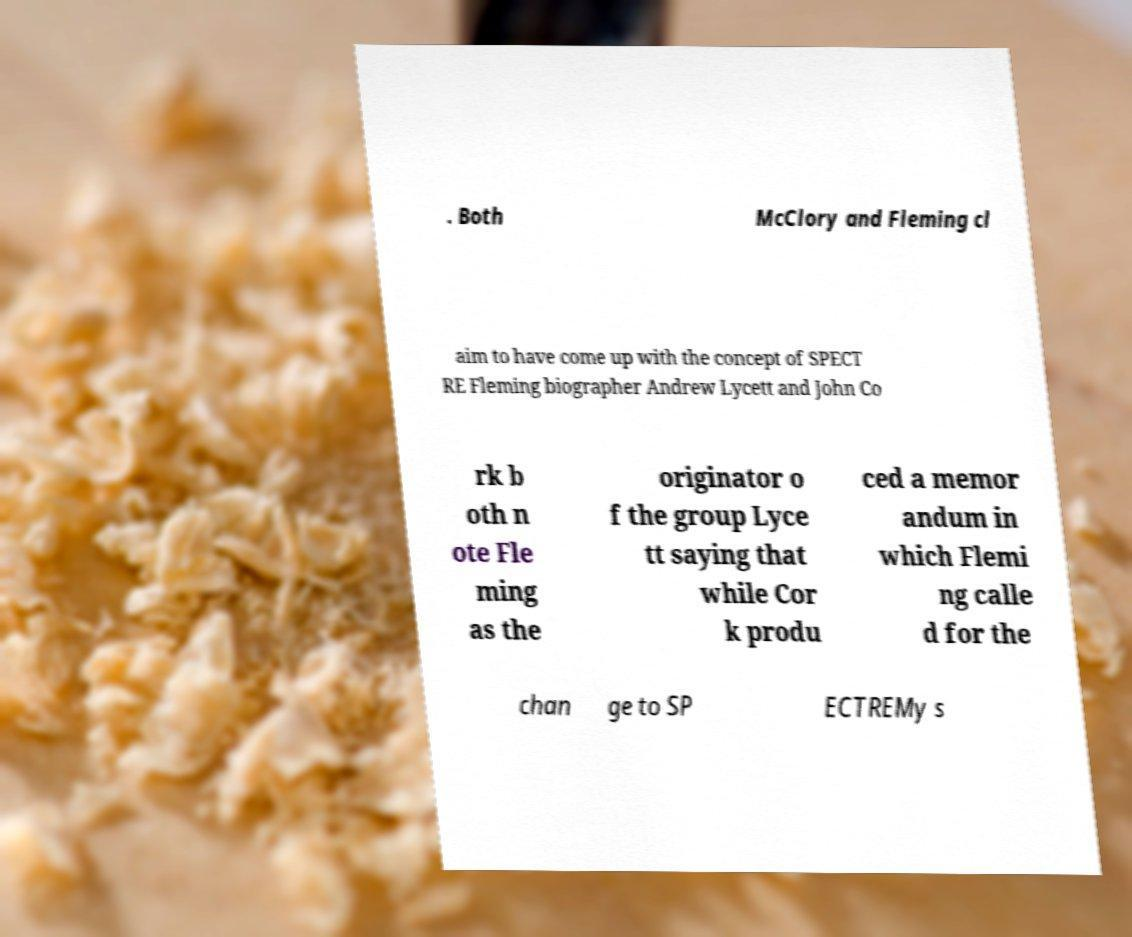Please identify and transcribe the text found in this image. . Both McClory and Fleming cl aim to have come up with the concept of SPECT RE Fleming biographer Andrew Lycett and John Co rk b oth n ote Fle ming as the originator o f the group Lyce tt saying that while Cor k produ ced a memor andum in which Flemi ng calle d for the chan ge to SP ECTREMy s 